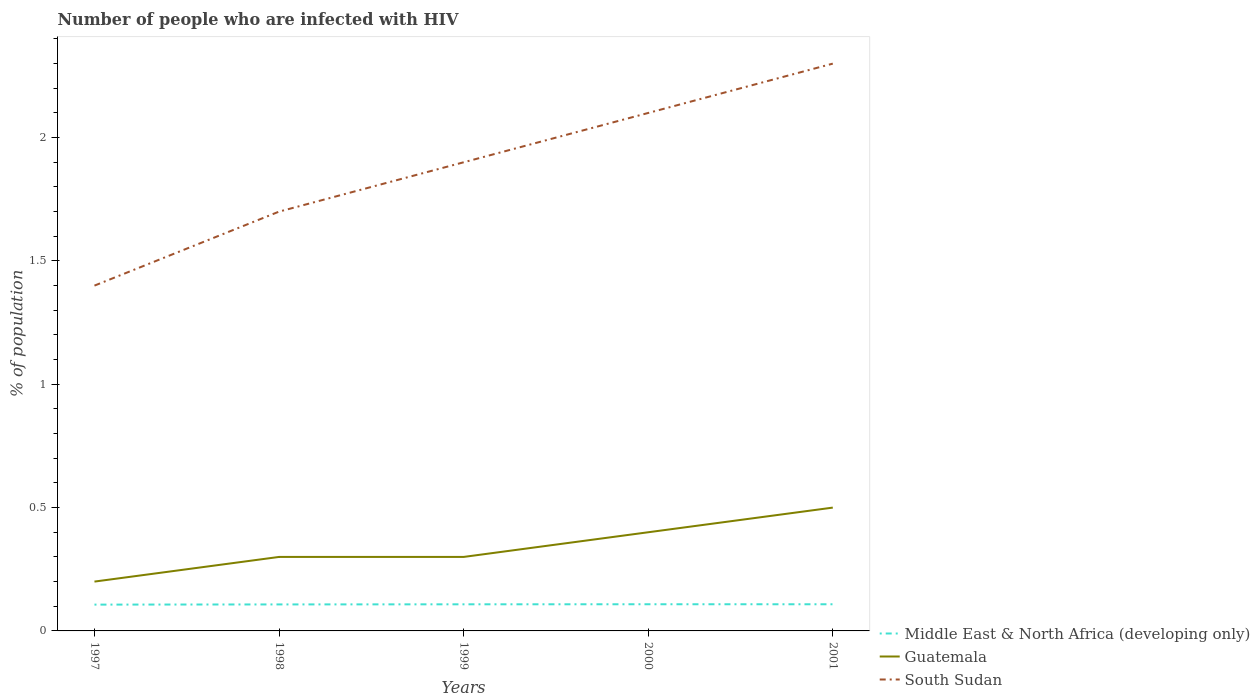How many different coloured lines are there?
Offer a terse response. 3. Is the number of lines equal to the number of legend labels?
Provide a short and direct response. Yes. Across all years, what is the maximum percentage of HIV infected population in in Middle East & North Africa (developing only)?
Your response must be concise. 0.11. What is the total percentage of HIV infected population in in South Sudan in the graph?
Keep it short and to the point. -0.2. What is the difference between the highest and the lowest percentage of HIV infected population in in South Sudan?
Your answer should be compact. 3. Is the percentage of HIV infected population in in Middle East & North Africa (developing only) strictly greater than the percentage of HIV infected population in in Guatemala over the years?
Make the answer very short. Yes. How many years are there in the graph?
Your response must be concise. 5. What is the difference between two consecutive major ticks on the Y-axis?
Your answer should be very brief. 0.5. Are the values on the major ticks of Y-axis written in scientific E-notation?
Offer a terse response. No. Does the graph contain any zero values?
Your answer should be compact. No. How are the legend labels stacked?
Offer a terse response. Vertical. What is the title of the graph?
Make the answer very short. Number of people who are infected with HIV. What is the label or title of the X-axis?
Your response must be concise. Years. What is the label or title of the Y-axis?
Keep it short and to the point. % of population. What is the % of population in Middle East & North Africa (developing only) in 1997?
Give a very brief answer. 0.11. What is the % of population in South Sudan in 1997?
Offer a very short reply. 1.4. What is the % of population in Middle East & North Africa (developing only) in 1998?
Offer a very short reply. 0.11. What is the % of population of Guatemala in 1998?
Your answer should be compact. 0.3. What is the % of population of Middle East & North Africa (developing only) in 1999?
Your answer should be very brief. 0.11. What is the % of population of Guatemala in 1999?
Offer a very short reply. 0.3. What is the % of population of Middle East & North Africa (developing only) in 2000?
Offer a terse response. 0.11. What is the % of population of Guatemala in 2000?
Offer a very short reply. 0.4. What is the % of population in South Sudan in 2000?
Provide a short and direct response. 2.1. What is the % of population in Middle East & North Africa (developing only) in 2001?
Keep it short and to the point. 0.11. What is the % of population of South Sudan in 2001?
Provide a short and direct response. 2.3. Across all years, what is the maximum % of population in Middle East & North Africa (developing only)?
Your answer should be compact. 0.11. Across all years, what is the maximum % of population in Guatemala?
Offer a terse response. 0.5. Across all years, what is the minimum % of population of Middle East & North Africa (developing only)?
Keep it short and to the point. 0.11. Across all years, what is the minimum % of population of Guatemala?
Keep it short and to the point. 0.2. What is the total % of population of Middle East & North Africa (developing only) in the graph?
Your response must be concise. 0.54. What is the total % of population of South Sudan in the graph?
Provide a succinct answer. 9.4. What is the difference between the % of population of Middle East & North Africa (developing only) in 1997 and that in 1998?
Make the answer very short. -0. What is the difference between the % of population of South Sudan in 1997 and that in 1998?
Provide a short and direct response. -0.3. What is the difference between the % of population in Middle East & North Africa (developing only) in 1997 and that in 1999?
Offer a terse response. -0. What is the difference between the % of population in Middle East & North Africa (developing only) in 1997 and that in 2000?
Keep it short and to the point. -0. What is the difference between the % of population in South Sudan in 1997 and that in 2000?
Ensure brevity in your answer.  -0.7. What is the difference between the % of population of Middle East & North Africa (developing only) in 1997 and that in 2001?
Your response must be concise. -0. What is the difference between the % of population of South Sudan in 1997 and that in 2001?
Give a very brief answer. -0.9. What is the difference between the % of population of Middle East & North Africa (developing only) in 1998 and that in 1999?
Make the answer very short. -0. What is the difference between the % of population in South Sudan in 1998 and that in 1999?
Your answer should be compact. -0.2. What is the difference between the % of population in Middle East & North Africa (developing only) in 1998 and that in 2000?
Give a very brief answer. -0. What is the difference between the % of population of Middle East & North Africa (developing only) in 1998 and that in 2001?
Provide a short and direct response. -0. What is the difference between the % of population in Guatemala in 1998 and that in 2001?
Provide a succinct answer. -0.2. What is the difference between the % of population of Middle East & North Africa (developing only) in 1999 and that in 2000?
Your answer should be compact. -0. What is the difference between the % of population in Guatemala in 1999 and that in 2000?
Keep it short and to the point. -0.1. What is the difference between the % of population in South Sudan in 1999 and that in 2000?
Offer a very short reply. -0.2. What is the difference between the % of population in Middle East & North Africa (developing only) in 1999 and that in 2001?
Provide a short and direct response. -0. What is the difference between the % of population in Guatemala in 1999 and that in 2001?
Your answer should be compact. -0.2. What is the difference between the % of population in South Sudan in 2000 and that in 2001?
Provide a short and direct response. -0.2. What is the difference between the % of population of Middle East & North Africa (developing only) in 1997 and the % of population of Guatemala in 1998?
Give a very brief answer. -0.19. What is the difference between the % of population of Middle East & North Africa (developing only) in 1997 and the % of population of South Sudan in 1998?
Ensure brevity in your answer.  -1.59. What is the difference between the % of population in Guatemala in 1997 and the % of population in South Sudan in 1998?
Your answer should be compact. -1.5. What is the difference between the % of population of Middle East & North Africa (developing only) in 1997 and the % of population of Guatemala in 1999?
Make the answer very short. -0.19. What is the difference between the % of population in Middle East & North Africa (developing only) in 1997 and the % of population in South Sudan in 1999?
Offer a very short reply. -1.79. What is the difference between the % of population in Guatemala in 1997 and the % of population in South Sudan in 1999?
Your answer should be compact. -1.7. What is the difference between the % of population of Middle East & North Africa (developing only) in 1997 and the % of population of Guatemala in 2000?
Your answer should be very brief. -0.29. What is the difference between the % of population in Middle East & North Africa (developing only) in 1997 and the % of population in South Sudan in 2000?
Your answer should be very brief. -1.99. What is the difference between the % of population in Guatemala in 1997 and the % of population in South Sudan in 2000?
Offer a terse response. -1.9. What is the difference between the % of population of Middle East & North Africa (developing only) in 1997 and the % of population of Guatemala in 2001?
Provide a succinct answer. -0.39. What is the difference between the % of population of Middle East & North Africa (developing only) in 1997 and the % of population of South Sudan in 2001?
Offer a terse response. -2.19. What is the difference between the % of population in Guatemala in 1997 and the % of population in South Sudan in 2001?
Make the answer very short. -2.1. What is the difference between the % of population in Middle East & North Africa (developing only) in 1998 and the % of population in Guatemala in 1999?
Your answer should be very brief. -0.19. What is the difference between the % of population of Middle East & North Africa (developing only) in 1998 and the % of population of South Sudan in 1999?
Provide a short and direct response. -1.79. What is the difference between the % of population of Middle East & North Africa (developing only) in 1998 and the % of population of Guatemala in 2000?
Provide a succinct answer. -0.29. What is the difference between the % of population of Middle East & North Africa (developing only) in 1998 and the % of population of South Sudan in 2000?
Your answer should be compact. -1.99. What is the difference between the % of population in Middle East & North Africa (developing only) in 1998 and the % of population in Guatemala in 2001?
Ensure brevity in your answer.  -0.39. What is the difference between the % of population of Middle East & North Africa (developing only) in 1998 and the % of population of South Sudan in 2001?
Keep it short and to the point. -2.19. What is the difference between the % of population of Middle East & North Africa (developing only) in 1999 and the % of population of Guatemala in 2000?
Give a very brief answer. -0.29. What is the difference between the % of population in Middle East & North Africa (developing only) in 1999 and the % of population in South Sudan in 2000?
Your response must be concise. -1.99. What is the difference between the % of population of Middle East & North Africa (developing only) in 1999 and the % of population of Guatemala in 2001?
Provide a short and direct response. -0.39. What is the difference between the % of population in Middle East & North Africa (developing only) in 1999 and the % of population in South Sudan in 2001?
Your response must be concise. -2.19. What is the difference between the % of population of Guatemala in 1999 and the % of population of South Sudan in 2001?
Offer a very short reply. -2. What is the difference between the % of population of Middle East & North Africa (developing only) in 2000 and the % of population of Guatemala in 2001?
Make the answer very short. -0.39. What is the difference between the % of population of Middle East & North Africa (developing only) in 2000 and the % of population of South Sudan in 2001?
Offer a very short reply. -2.19. What is the difference between the % of population in Guatemala in 2000 and the % of population in South Sudan in 2001?
Keep it short and to the point. -1.9. What is the average % of population of Middle East & North Africa (developing only) per year?
Ensure brevity in your answer.  0.11. What is the average % of population in Guatemala per year?
Make the answer very short. 0.34. What is the average % of population of South Sudan per year?
Make the answer very short. 1.88. In the year 1997, what is the difference between the % of population of Middle East & North Africa (developing only) and % of population of Guatemala?
Provide a succinct answer. -0.09. In the year 1997, what is the difference between the % of population of Middle East & North Africa (developing only) and % of population of South Sudan?
Your answer should be compact. -1.29. In the year 1998, what is the difference between the % of population of Middle East & North Africa (developing only) and % of population of Guatemala?
Your answer should be compact. -0.19. In the year 1998, what is the difference between the % of population of Middle East & North Africa (developing only) and % of population of South Sudan?
Offer a very short reply. -1.59. In the year 1998, what is the difference between the % of population in Guatemala and % of population in South Sudan?
Give a very brief answer. -1.4. In the year 1999, what is the difference between the % of population in Middle East & North Africa (developing only) and % of population in Guatemala?
Your response must be concise. -0.19. In the year 1999, what is the difference between the % of population of Middle East & North Africa (developing only) and % of population of South Sudan?
Ensure brevity in your answer.  -1.79. In the year 1999, what is the difference between the % of population of Guatemala and % of population of South Sudan?
Your response must be concise. -1.6. In the year 2000, what is the difference between the % of population in Middle East & North Africa (developing only) and % of population in Guatemala?
Make the answer very short. -0.29. In the year 2000, what is the difference between the % of population in Middle East & North Africa (developing only) and % of population in South Sudan?
Your answer should be very brief. -1.99. In the year 2001, what is the difference between the % of population in Middle East & North Africa (developing only) and % of population in Guatemala?
Provide a succinct answer. -0.39. In the year 2001, what is the difference between the % of population in Middle East & North Africa (developing only) and % of population in South Sudan?
Provide a short and direct response. -2.19. In the year 2001, what is the difference between the % of population of Guatemala and % of population of South Sudan?
Ensure brevity in your answer.  -1.8. What is the ratio of the % of population in Middle East & North Africa (developing only) in 1997 to that in 1998?
Ensure brevity in your answer.  0.99. What is the ratio of the % of population of South Sudan in 1997 to that in 1998?
Your response must be concise. 0.82. What is the ratio of the % of population in Middle East & North Africa (developing only) in 1997 to that in 1999?
Offer a very short reply. 0.99. What is the ratio of the % of population in South Sudan in 1997 to that in 1999?
Give a very brief answer. 0.74. What is the ratio of the % of population in Middle East & North Africa (developing only) in 1997 to that in 2000?
Your answer should be very brief. 0.99. What is the ratio of the % of population in South Sudan in 1997 to that in 2000?
Make the answer very short. 0.67. What is the ratio of the % of population of Middle East & North Africa (developing only) in 1997 to that in 2001?
Provide a short and direct response. 0.99. What is the ratio of the % of population of South Sudan in 1997 to that in 2001?
Keep it short and to the point. 0.61. What is the ratio of the % of population of Guatemala in 1998 to that in 1999?
Your response must be concise. 1. What is the ratio of the % of population of South Sudan in 1998 to that in 1999?
Your response must be concise. 0.89. What is the ratio of the % of population in South Sudan in 1998 to that in 2000?
Give a very brief answer. 0.81. What is the ratio of the % of population in Middle East & North Africa (developing only) in 1998 to that in 2001?
Provide a succinct answer. 0.99. What is the ratio of the % of population of Guatemala in 1998 to that in 2001?
Your answer should be compact. 0.6. What is the ratio of the % of population of South Sudan in 1998 to that in 2001?
Your answer should be compact. 0.74. What is the ratio of the % of population of South Sudan in 1999 to that in 2000?
Offer a terse response. 0.9. What is the ratio of the % of population of South Sudan in 1999 to that in 2001?
Give a very brief answer. 0.83. What is the ratio of the % of population of Middle East & North Africa (developing only) in 2000 to that in 2001?
Your answer should be compact. 1. What is the ratio of the % of population in Guatemala in 2000 to that in 2001?
Provide a succinct answer. 0.8. What is the difference between the highest and the lowest % of population of Middle East & North Africa (developing only)?
Offer a very short reply. 0. What is the difference between the highest and the lowest % of population in Guatemala?
Your response must be concise. 0.3. 